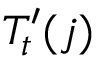Convert formula to latex. <formula><loc_0><loc_0><loc_500><loc_500>T _ { t } ^ { \prime } ( j )</formula> 